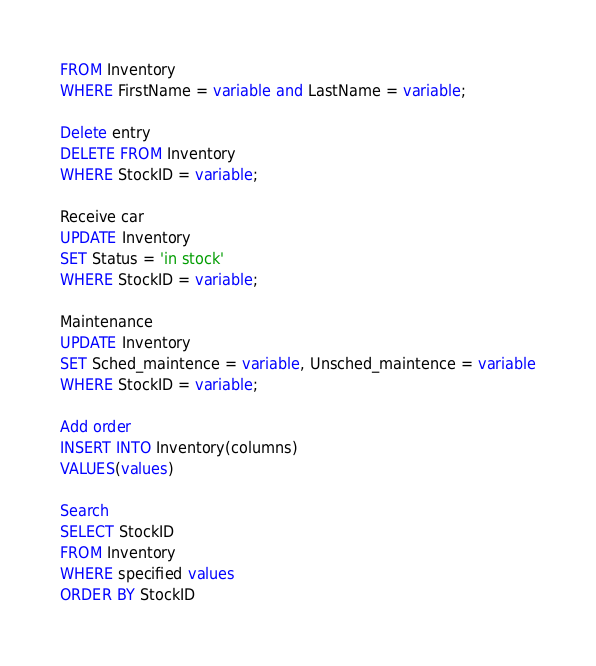Convert code to text. <code><loc_0><loc_0><loc_500><loc_500><_SQL_>FROM Inventory
WHERE FirstName = variable and LastName = variable;

Delete entry
DELETE FROM Inventory
WHERE StockID = variable;

Receive car
UPDATE Inventory
SET Status = 'in stock' 
WHERE StockID = variable;

Maintenance
UPDATE Inventory
SET Sched_maintence = variable, Unsched_maintence = variable
WHERE StockID = variable;

Add order
INSERT INTO Inventory(columns)
VALUES(values)

Search
SELECT StockID
FROM Inventory
WHERE specified values
ORDER BY StockID</code> 